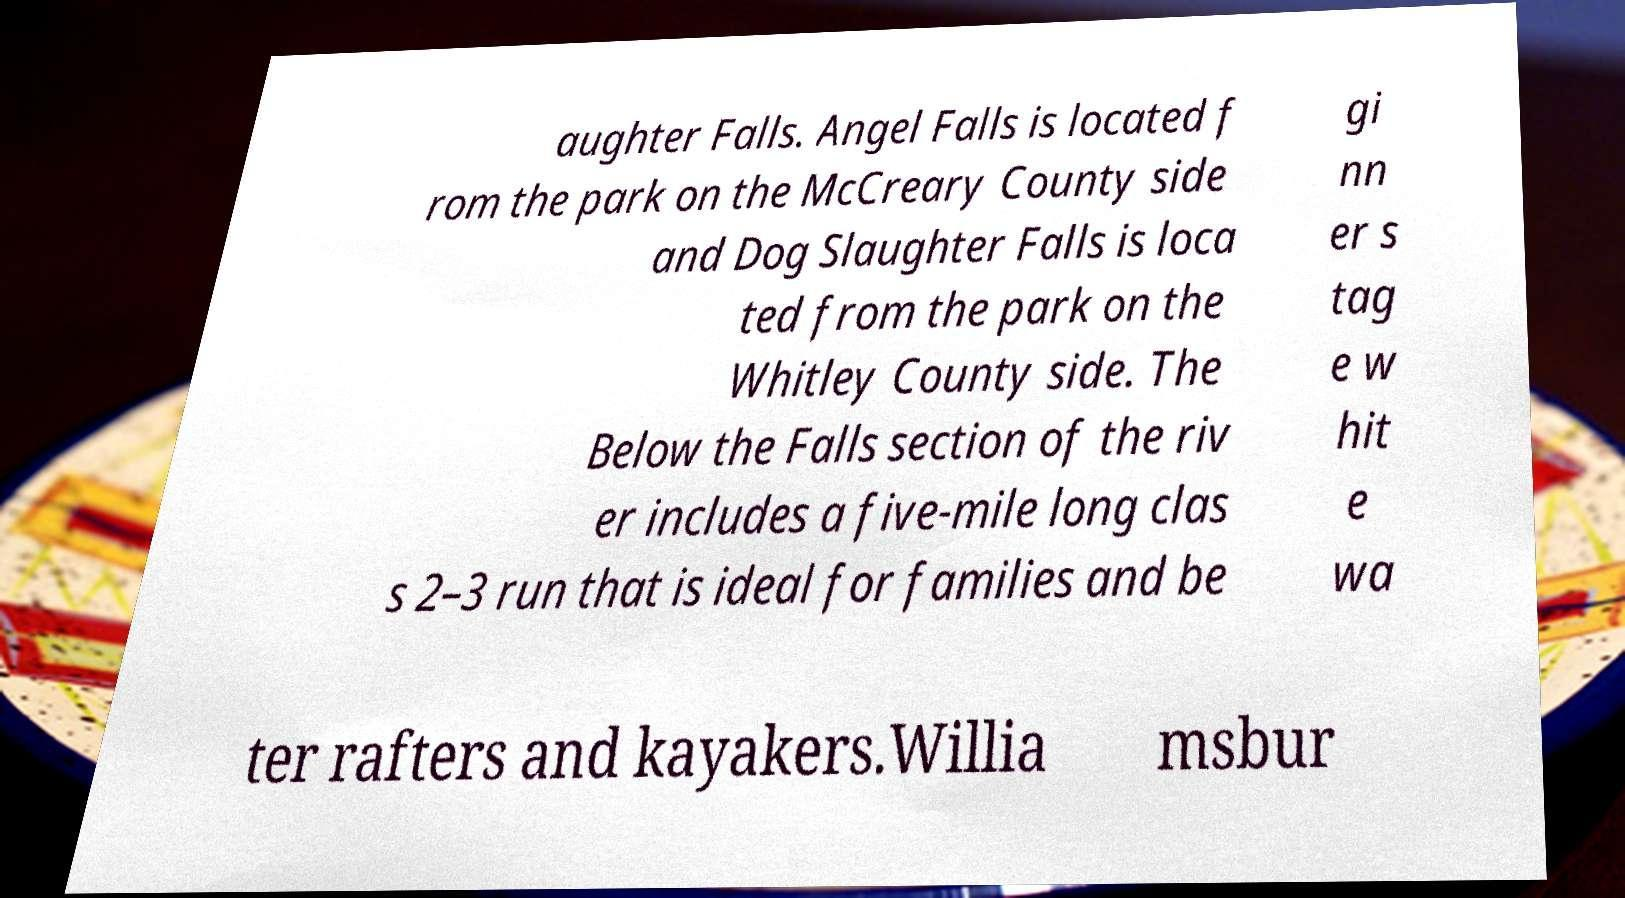I need the written content from this picture converted into text. Can you do that? aughter Falls. Angel Falls is located f rom the park on the McCreary County side and Dog Slaughter Falls is loca ted from the park on the Whitley County side. The Below the Falls section of the riv er includes a five-mile long clas s 2–3 run that is ideal for families and be gi nn er s tag e w hit e wa ter rafters and kayakers.Willia msbur 